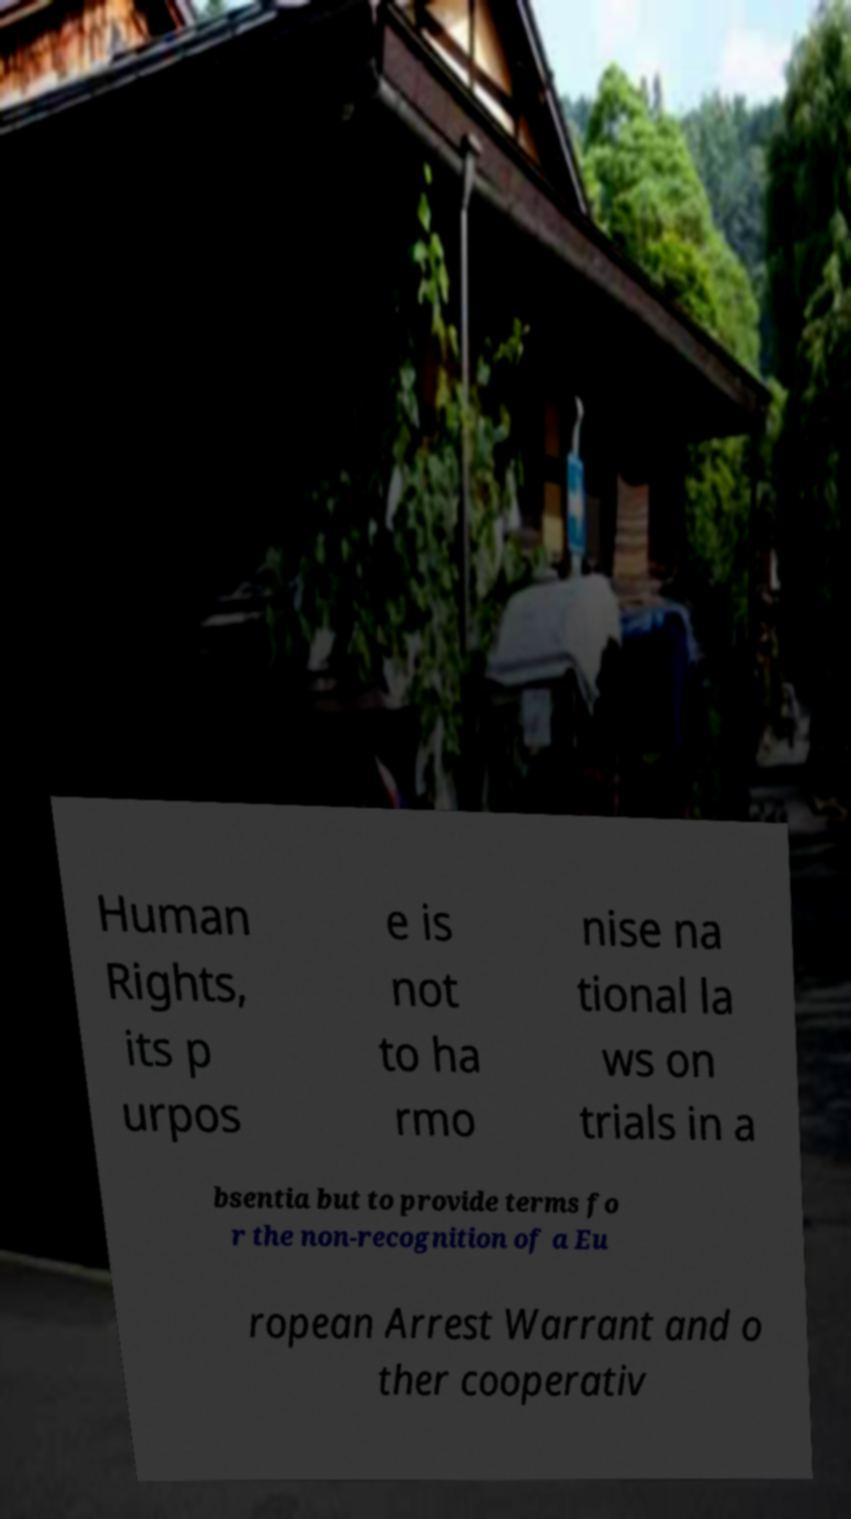What messages or text are displayed in this image? I need them in a readable, typed format. Human Rights, its p urpos e is not to ha rmo nise na tional la ws on trials in a bsentia but to provide terms fo r the non-recognition of a Eu ropean Arrest Warrant and o ther cooperativ 